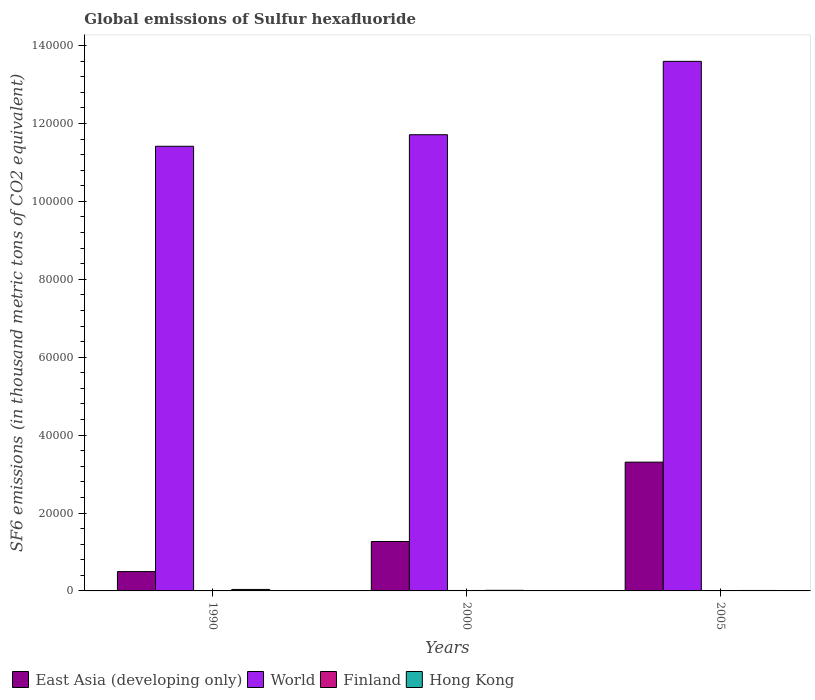How many different coloured bars are there?
Your answer should be compact. 4. Are the number of bars per tick equal to the number of legend labels?
Offer a very short reply. Yes. Are the number of bars on each tick of the X-axis equal?
Keep it short and to the point. Yes. How many bars are there on the 2nd tick from the left?
Your answer should be compact. 4. How many bars are there on the 3rd tick from the right?
Ensure brevity in your answer.  4. What is the global emissions of Sulfur hexafluoride in East Asia (developing only) in 2005?
Offer a terse response. 3.31e+04. Across all years, what is the maximum global emissions of Sulfur hexafluoride in Hong Kong?
Provide a short and direct response. 379. Across all years, what is the minimum global emissions of Sulfur hexafluoride in East Asia (developing only)?
Offer a terse response. 4959.9. In which year was the global emissions of Sulfur hexafluoride in Hong Kong maximum?
Offer a terse response. 1990. In which year was the global emissions of Sulfur hexafluoride in World minimum?
Give a very brief answer. 1990. What is the total global emissions of Sulfur hexafluoride in Finland in the graph?
Provide a succinct answer. 263.2. What is the difference between the global emissions of Sulfur hexafluoride in East Asia (developing only) in 1990 and that in 2005?
Provide a succinct answer. -2.81e+04. What is the difference between the global emissions of Sulfur hexafluoride in Hong Kong in 2000 and the global emissions of Sulfur hexafluoride in East Asia (developing only) in 2005?
Ensure brevity in your answer.  -3.29e+04. What is the average global emissions of Sulfur hexafluoride in Finland per year?
Give a very brief answer. 87.73. In the year 1990, what is the difference between the global emissions of Sulfur hexafluoride in World and global emissions of Sulfur hexafluoride in Finland?
Your answer should be very brief. 1.14e+05. In how many years, is the global emissions of Sulfur hexafluoride in Hong Kong greater than 32000 thousand metric tons?
Provide a short and direct response. 0. What is the ratio of the global emissions of Sulfur hexafluoride in East Asia (developing only) in 2000 to that in 2005?
Ensure brevity in your answer.  0.38. Is the global emissions of Sulfur hexafluoride in Finland in 1990 less than that in 2000?
Your answer should be very brief. Yes. Is the difference between the global emissions of Sulfur hexafluoride in World in 1990 and 2005 greater than the difference between the global emissions of Sulfur hexafluoride in Finland in 1990 and 2005?
Give a very brief answer. No. What is the difference between the highest and the second highest global emissions of Sulfur hexafluoride in East Asia (developing only)?
Your answer should be compact. 2.04e+04. What is the difference between the highest and the lowest global emissions of Sulfur hexafluoride in World?
Ensure brevity in your answer.  2.18e+04. In how many years, is the global emissions of Sulfur hexafluoride in Finland greater than the average global emissions of Sulfur hexafluoride in Finland taken over all years?
Offer a terse response. 2. Is the sum of the global emissions of Sulfur hexafluoride in East Asia (developing only) in 1990 and 2005 greater than the maximum global emissions of Sulfur hexafluoride in Finland across all years?
Provide a succinct answer. Yes. What does the 1st bar from the right in 2005 represents?
Your answer should be compact. Hong Kong. What is the difference between two consecutive major ticks on the Y-axis?
Your answer should be very brief. 2.00e+04. Are the values on the major ticks of Y-axis written in scientific E-notation?
Your answer should be compact. No. Where does the legend appear in the graph?
Provide a succinct answer. Bottom left. What is the title of the graph?
Offer a very short reply. Global emissions of Sulfur hexafluoride. What is the label or title of the X-axis?
Your response must be concise. Years. What is the label or title of the Y-axis?
Provide a short and direct response. SF6 emissions (in thousand metric tons of CO2 equivalent). What is the SF6 emissions (in thousand metric tons of CO2 equivalent) in East Asia (developing only) in 1990?
Your response must be concise. 4959.9. What is the SF6 emissions (in thousand metric tons of CO2 equivalent) of World in 1990?
Offer a very short reply. 1.14e+05. What is the SF6 emissions (in thousand metric tons of CO2 equivalent) in Finland in 1990?
Provide a succinct answer. 98.4. What is the SF6 emissions (in thousand metric tons of CO2 equivalent) in Hong Kong in 1990?
Your answer should be compact. 379. What is the SF6 emissions (in thousand metric tons of CO2 equivalent) of East Asia (developing only) in 2000?
Your answer should be very brief. 1.27e+04. What is the SF6 emissions (in thousand metric tons of CO2 equivalent) of World in 2000?
Provide a succinct answer. 1.17e+05. What is the SF6 emissions (in thousand metric tons of CO2 equivalent) of Finland in 2000?
Your response must be concise. 113.9. What is the SF6 emissions (in thousand metric tons of CO2 equivalent) of Hong Kong in 2000?
Make the answer very short. 155.3. What is the SF6 emissions (in thousand metric tons of CO2 equivalent) in East Asia (developing only) in 2005?
Offer a terse response. 3.31e+04. What is the SF6 emissions (in thousand metric tons of CO2 equivalent) of World in 2005?
Provide a short and direct response. 1.36e+05. What is the SF6 emissions (in thousand metric tons of CO2 equivalent) of Finland in 2005?
Provide a succinct answer. 50.9. What is the SF6 emissions (in thousand metric tons of CO2 equivalent) in Hong Kong in 2005?
Your answer should be very brief. 119. Across all years, what is the maximum SF6 emissions (in thousand metric tons of CO2 equivalent) in East Asia (developing only)?
Offer a terse response. 3.31e+04. Across all years, what is the maximum SF6 emissions (in thousand metric tons of CO2 equivalent) in World?
Provide a short and direct response. 1.36e+05. Across all years, what is the maximum SF6 emissions (in thousand metric tons of CO2 equivalent) in Finland?
Make the answer very short. 113.9. Across all years, what is the maximum SF6 emissions (in thousand metric tons of CO2 equivalent) of Hong Kong?
Ensure brevity in your answer.  379. Across all years, what is the minimum SF6 emissions (in thousand metric tons of CO2 equivalent) in East Asia (developing only)?
Keep it short and to the point. 4959.9. Across all years, what is the minimum SF6 emissions (in thousand metric tons of CO2 equivalent) of World?
Your answer should be compact. 1.14e+05. Across all years, what is the minimum SF6 emissions (in thousand metric tons of CO2 equivalent) of Finland?
Your answer should be compact. 50.9. Across all years, what is the minimum SF6 emissions (in thousand metric tons of CO2 equivalent) of Hong Kong?
Ensure brevity in your answer.  119. What is the total SF6 emissions (in thousand metric tons of CO2 equivalent) in East Asia (developing only) in the graph?
Ensure brevity in your answer.  5.07e+04. What is the total SF6 emissions (in thousand metric tons of CO2 equivalent) in World in the graph?
Make the answer very short. 3.67e+05. What is the total SF6 emissions (in thousand metric tons of CO2 equivalent) in Finland in the graph?
Give a very brief answer. 263.2. What is the total SF6 emissions (in thousand metric tons of CO2 equivalent) of Hong Kong in the graph?
Your answer should be very brief. 653.3. What is the difference between the SF6 emissions (in thousand metric tons of CO2 equivalent) in East Asia (developing only) in 1990 and that in 2000?
Make the answer very short. -7723.7. What is the difference between the SF6 emissions (in thousand metric tons of CO2 equivalent) in World in 1990 and that in 2000?
Offer a terse response. -2964.6. What is the difference between the SF6 emissions (in thousand metric tons of CO2 equivalent) in Finland in 1990 and that in 2000?
Give a very brief answer. -15.5. What is the difference between the SF6 emissions (in thousand metric tons of CO2 equivalent) in Hong Kong in 1990 and that in 2000?
Provide a short and direct response. 223.7. What is the difference between the SF6 emissions (in thousand metric tons of CO2 equivalent) of East Asia (developing only) in 1990 and that in 2005?
Offer a terse response. -2.81e+04. What is the difference between the SF6 emissions (in thousand metric tons of CO2 equivalent) of World in 1990 and that in 2005?
Your answer should be very brief. -2.18e+04. What is the difference between the SF6 emissions (in thousand metric tons of CO2 equivalent) in Finland in 1990 and that in 2005?
Offer a terse response. 47.5. What is the difference between the SF6 emissions (in thousand metric tons of CO2 equivalent) in Hong Kong in 1990 and that in 2005?
Ensure brevity in your answer.  260. What is the difference between the SF6 emissions (in thousand metric tons of CO2 equivalent) in East Asia (developing only) in 2000 and that in 2005?
Offer a terse response. -2.04e+04. What is the difference between the SF6 emissions (in thousand metric tons of CO2 equivalent) of World in 2000 and that in 2005?
Your answer should be very brief. -1.88e+04. What is the difference between the SF6 emissions (in thousand metric tons of CO2 equivalent) of Finland in 2000 and that in 2005?
Offer a very short reply. 63. What is the difference between the SF6 emissions (in thousand metric tons of CO2 equivalent) in Hong Kong in 2000 and that in 2005?
Give a very brief answer. 36.3. What is the difference between the SF6 emissions (in thousand metric tons of CO2 equivalent) of East Asia (developing only) in 1990 and the SF6 emissions (in thousand metric tons of CO2 equivalent) of World in 2000?
Make the answer very short. -1.12e+05. What is the difference between the SF6 emissions (in thousand metric tons of CO2 equivalent) of East Asia (developing only) in 1990 and the SF6 emissions (in thousand metric tons of CO2 equivalent) of Finland in 2000?
Your response must be concise. 4846. What is the difference between the SF6 emissions (in thousand metric tons of CO2 equivalent) in East Asia (developing only) in 1990 and the SF6 emissions (in thousand metric tons of CO2 equivalent) in Hong Kong in 2000?
Keep it short and to the point. 4804.6. What is the difference between the SF6 emissions (in thousand metric tons of CO2 equivalent) in World in 1990 and the SF6 emissions (in thousand metric tons of CO2 equivalent) in Finland in 2000?
Ensure brevity in your answer.  1.14e+05. What is the difference between the SF6 emissions (in thousand metric tons of CO2 equivalent) in World in 1990 and the SF6 emissions (in thousand metric tons of CO2 equivalent) in Hong Kong in 2000?
Provide a succinct answer. 1.14e+05. What is the difference between the SF6 emissions (in thousand metric tons of CO2 equivalent) of Finland in 1990 and the SF6 emissions (in thousand metric tons of CO2 equivalent) of Hong Kong in 2000?
Your response must be concise. -56.9. What is the difference between the SF6 emissions (in thousand metric tons of CO2 equivalent) in East Asia (developing only) in 1990 and the SF6 emissions (in thousand metric tons of CO2 equivalent) in World in 2005?
Provide a succinct answer. -1.31e+05. What is the difference between the SF6 emissions (in thousand metric tons of CO2 equivalent) in East Asia (developing only) in 1990 and the SF6 emissions (in thousand metric tons of CO2 equivalent) in Finland in 2005?
Provide a short and direct response. 4909. What is the difference between the SF6 emissions (in thousand metric tons of CO2 equivalent) of East Asia (developing only) in 1990 and the SF6 emissions (in thousand metric tons of CO2 equivalent) of Hong Kong in 2005?
Your answer should be compact. 4840.9. What is the difference between the SF6 emissions (in thousand metric tons of CO2 equivalent) in World in 1990 and the SF6 emissions (in thousand metric tons of CO2 equivalent) in Finland in 2005?
Make the answer very short. 1.14e+05. What is the difference between the SF6 emissions (in thousand metric tons of CO2 equivalent) of World in 1990 and the SF6 emissions (in thousand metric tons of CO2 equivalent) of Hong Kong in 2005?
Your response must be concise. 1.14e+05. What is the difference between the SF6 emissions (in thousand metric tons of CO2 equivalent) in Finland in 1990 and the SF6 emissions (in thousand metric tons of CO2 equivalent) in Hong Kong in 2005?
Offer a very short reply. -20.6. What is the difference between the SF6 emissions (in thousand metric tons of CO2 equivalent) of East Asia (developing only) in 2000 and the SF6 emissions (in thousand metric tons of CO2 equivalent) of World in 2005?
Offer a terse response. -1.23e+05. What is the difference between the SF6 emissions (in thousand metric tons of CO2 equivalent) of East Asia (developing only) in 2000 and the SF6 emissions (in thousand metric tons of CO2 equivalent) of Finland in 2005?
Your answer should be very brief. 1.26e+04. What is the difference between the SF6 emissions (in thousand metric tons of CO2 equivalent) in East Asia (developing only) in 2000 and the SF6 emissions (in thousand metric tons of CO2 equivalent) in Hong Kong in 2005?
Offer a very short reply. 1.26e+04. What is the difference between the SF6 emissions (in thousand metric tons of CO2 equivalent) of World in 2000 and the SF6 emissions (in thousand metric tons of CO2 equivalent) of Finland in 2005?
Your response must be concise. 1.17e+05. What is the difference between the SF6 emissions (in thousand metric tons of CO2 equivalent) of World in 2000 and the SF6 emissions (in thousand metric tons of CO2 equivalent) of Hong Kong in 2005?
Give a very brief answer. 1.17e+05. What is the difference between the SF6 emissions (in thousand metric tons of CO2 equivalent) of Finland in 2000 and the SF6 emissions (in thousand metric tons of CO2 equivalent) of Hong Kong in 2005?
Ensure brevity in your answer.  -5.1. What is the average SF6 emissions (in thousand metric tons of CO2 equivalent) in East Asia (developing only) per year?
Keep it short and to the point. 1.69e+04. What is the average SF6 emissions (in thousand metric tons of CO2 equivalent) of World per year?
Ensure brevity in your answer.  1.22e+05. What is the average SF6 emissions (in thousand metric tons of CO2 equivalent) of Finland per year?
Offer a terse response. 87.73. What is the average SF6 emissions (in thousand metric tons of CO2 equivalent) of Hong Kong per year?
Offer a terse response. 217.77. In the year 1990, what is the difference between the SF6 emissions (in thousand metric tons of CO2 equivalent) of East Asia (developing only) and SF6 emissions (in thousand metric tons of CO2 equivalent) of World?
Offer a terse response. -1.09e+05. In the year 1990, what is the difference between the SF6 emissions (in thousand metric tons of CO2 equivalent) in East Asia (developing only) and SF6 emissions (in thousand metric tons of CO2 equivalent) in Finland?
Keep it short and to the point. 4861.5. In the year 1990, what is the difference between the SF6 emissions (in thousand metric tons of CO2 equivalent) in East Asia (developing only) and SF6 emissions (in thousand metric tons of CO2 equivalent) in Hong Kong?
Provide a short and direct response. 4580.9. In the year 1990, what is the difference between the SF6 emissions (in thousand metric tons of CO2 equivalent) of World and SF6 emissions (in thousand metric tons of CO2 equivalent) of Finland?
Keep it short and to the point. 1.14e+05. In the year 1990, what is the difference between the SF6 emissions (in thousand metric tons of CO2 equivalent) of World and SF6 emissions (in thousand metric tons of CO2 equivalent) of Hong Kong?
Provide a short and direct response. 1.14e+05. In the year 1990, what is the difference between the SF6 emissions (in thousand metric tons of CO2 equivalent) in Finland and SF6 emissions (in thousand metric tons of CO2 equivalent) in Hong Kong?
Provide a succinct answer. -280.6. In the year 2000, what is the difference between the SF6 emissions (in thousand metric tons of CO2 equivalent) of East Asia (developing only) and SF6 emissions (in thousand metric tons of CO2 equivalent) of World?
Make the answer very short. -1.04e+05. In the year 2000, what is the difference between the SF6 emissions (in thousand metric tons of CO2 equivalent) in East Asia (developing only) and SF6 emissions (in thousand metric tons of CO2 equivalent) in Finland?
Offer a very short reply. 1.26e+04. In the year 2000, what is the difference between the SF6 emissions (in thousand metric tons of CO2 equivalent) of East Asia (developing only) and SF6 emissions (in thousand metric tons of CO2 equivalent) of Hong Kong?
Make the answer very short. 1.25e+04. In the year 2000, what is the difference between the SF6 emissions (in thousand metric tons of CO2 equivalent) of World and SF6 emissions (in thousand metric tons of CO2 equivalent) of Finland?
Ensure brevity in your answer.  1.17e+05. In the year 2000, what is the difference between the SF6 emissions (in thousand metric tons of CO2 equivalent) in World and SF6 emissions (in thousand metric tons of CO2 equivalent) in Hong Kong?
Provide a short and direct response. 1.17e+05. In the year 2000, what is the difference between the SF6 emissions (in thousand metric tons of CO2 equivalent) of Finland and SF6 emissions (in thousand metric tons of CO2 equivalent) of Hong Kong?
Offer a terse response. -41.4. In the year 2005, what is the difference between the SF6 emissions (in thousand metric tons of CO2 equivalent) in East Asia (developing only) and SF6 emissions (in thousand metric tons of CO2 equivalent) in World?
Your answer should be very brief. -1.03e+05. In the year 2005, what is the difference between the SF6 emissions (in thousand metric tons of CO2 equivalent) of East Asia (developing only) and SF6 emissions (in thousand metric tons of CO2 equivalent) of Finland?
Your answer should be compact. 3.30e+04. In the year 2005, what is the difference between the SF6 emissions (in thousand metric tons of CO2 equivalent) in East Asia (developing only) and SF6 emissions (in thousand metric tons of CO2 equivalent) in Hong Kong?
Offer a very short reply. 3.29e+04. In the year 2005, what is the difference between the SF6 emissions (in thousand metric tons of CO2 equivalent) in World and SF6 emissions (in thousand metric tons of CO2 equivalent) in Finland?
Offer a terse response. 1.36e+05. In the year 2005, what is the difference between the SF6 emissions (in thousand metric tons of CO2 equivalent) in World and SF6 emissions (in thousand metric tons of CO2 equivalent) in Hong Kong?
Provide a short and direct response. 1.36e+05. In the year 2005, what is the difference between the SF6 emissions (in thousand metric tons of CO2 equivalent) of Finland and SF6 emissions (in thousand metric tons of CO2 equivalent) of Hong Kong?
Your response must be concise. -68.1. What is the ratio of the SF6 emissions (in thousand metric tons of CO2 equivalent) in East Asia (developing only) in 1990 to that in 2000?
Offer a terse response. 0.39. What is the ratio of the SF6 emissions (in thousand metric tons of CO2 equivalent) of World in 1990 to that in 2000?
Keep it short and to the point. 0.97. What is the ratio of the SF6 emissions (in thousand metric tons of CO2 equivalent) of Finland in 1990 to that in 2000?
Your response must be concise. 0.86. What is the ratio of the SF6 emissions (in thousand metric tons of CO2 equivalent) in Hong Kong in 1990 to that in 2000?
Your response must be concise. 2.44. What is the ratio of the SF6 emissions (in thousand metric tons of CO2 equivalent) of World in 1990 to that in 2005?
Your answer should be compact. 0.84. What is the ratio of the SF6 emissions (in thousand metric tons of CO2 equivalent) in Finland in 1990 to that in 2005?
Your answer should be very brief. 1.93. What is the ratio of the SF6 emissions (in thousand metric tons of CO2 equivalent) of Hong Kong in 1990 to that in 2005?
Ensure brevity in your answer.  3.18. What is the ratio of the SF6 emissions (in thousand metric tons of CO2 equivalent) in East Asia (developing only) in 2000 to that in 2005?
Keep it short and to the point. 0.38. What is the ratio of the SF6 emissions (in thousand metric tons of CO2 equivalent) in World in 2000 to that in 2005?
Provide a short and direct response. 0.86. What is the ratio of the SF6 emissions (in thousand metric tons of CO2 equivalent) in Finland in 2000 to that in 2005?
Provide a short and direct response. 2.24. What is the ratio of the SF6 emissions (in thousand metric tons of CO2 equivalent) in Hong Kong in 2000 to that in 2005?
Make the answer very short. 1.3. What is the difference between the highest and the second highest SF6 emissions (in thousand metric tons of CO2 equivalent) of East Asia (developing only)?
Your response must be concise. 2.04e+04. What is the difference between the highest and the second highest SF6 emissions (in thousand metric tons of CO2 equivalent) in World?
Your response must be concise. 1.88e+04. What is the difference between the highest and the second highest SF6 emissions (in thousand metric tons of CO2 equivalent) in Finland?
Ensure brevity in your answer.  15.5. What is the difference between the highest and the second highest SF6 emissions (in thousand metric tons of CO2 equivalent) of Hong Kong?
Your answer should be very brief. 223.7. What is the difference between the highest and the lowest SF6 emissions (in thousand metric tons of CO2 equivalent) in East Asia (developing only)?
Give a very brief answer. 2.81e+04. What is the difference between the highest and the lowest SF6 emissions (in thousand metric tons of CO2 equivalent) of World?
Offer a very short reply. 2.18e+04. What is the difference between the highest and the lowest SF6 emissions (in thousand metric tons of CO2 equivalent) of Finland?
Your answer should be compact. 63. What is the difference between the highest and the lowest SF6 emissions (in thousand metric tons of CO2 equivalent) of Hong Kong?
Provide a succinct answer. 260. 